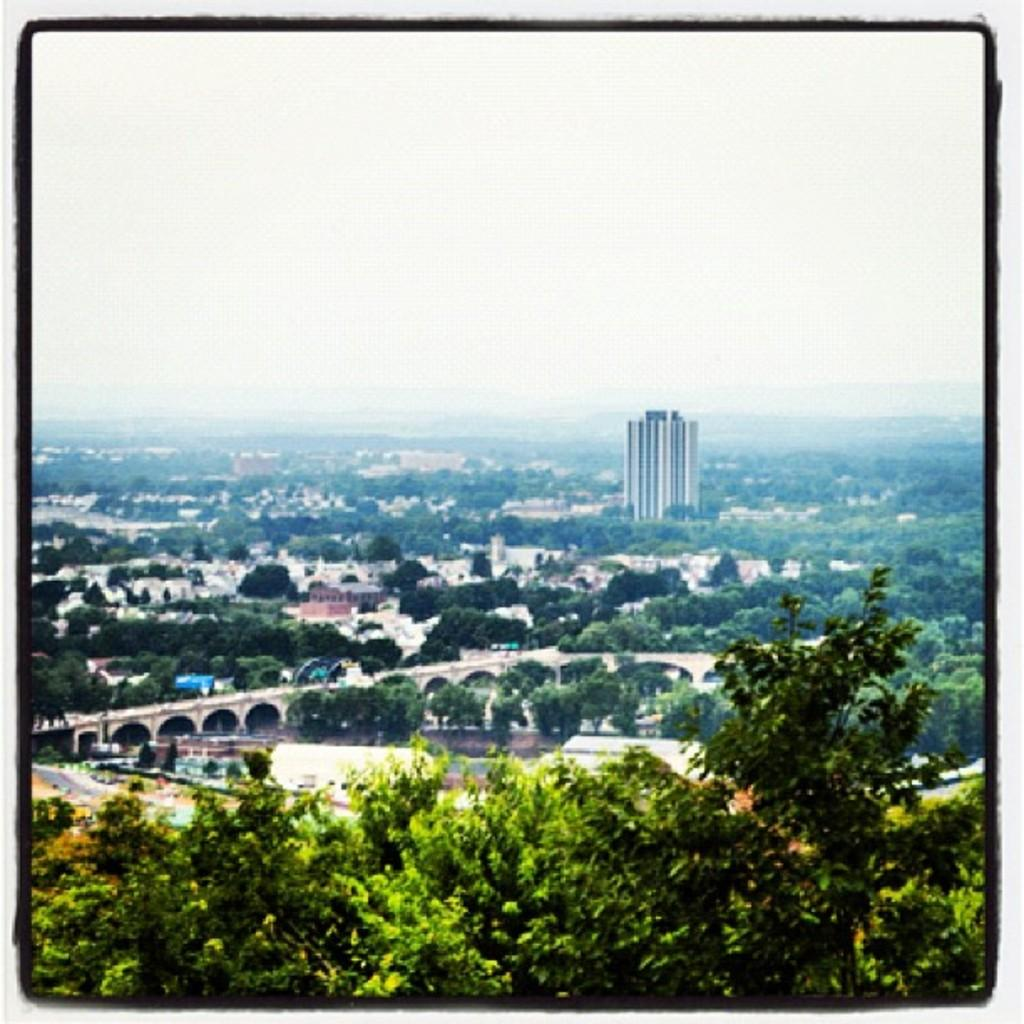What type of natural elements can be seen in the image? There are many trees in the image. What type of man-made structures are present in the image? There are buildings in the image. What type of transportation infrastructure is visible in the image? There is a road and a bridge in the image. What part of the natural environment is visible in the image? The sky is visible in the image. How is the image presented? The image has borders. How many clocks are hanging on the trees in the image? There are no clocks hanging on the trees in the image. What type of polish is being applied to the bridge in the image? There is no polish being applied to the bridge in the image. 